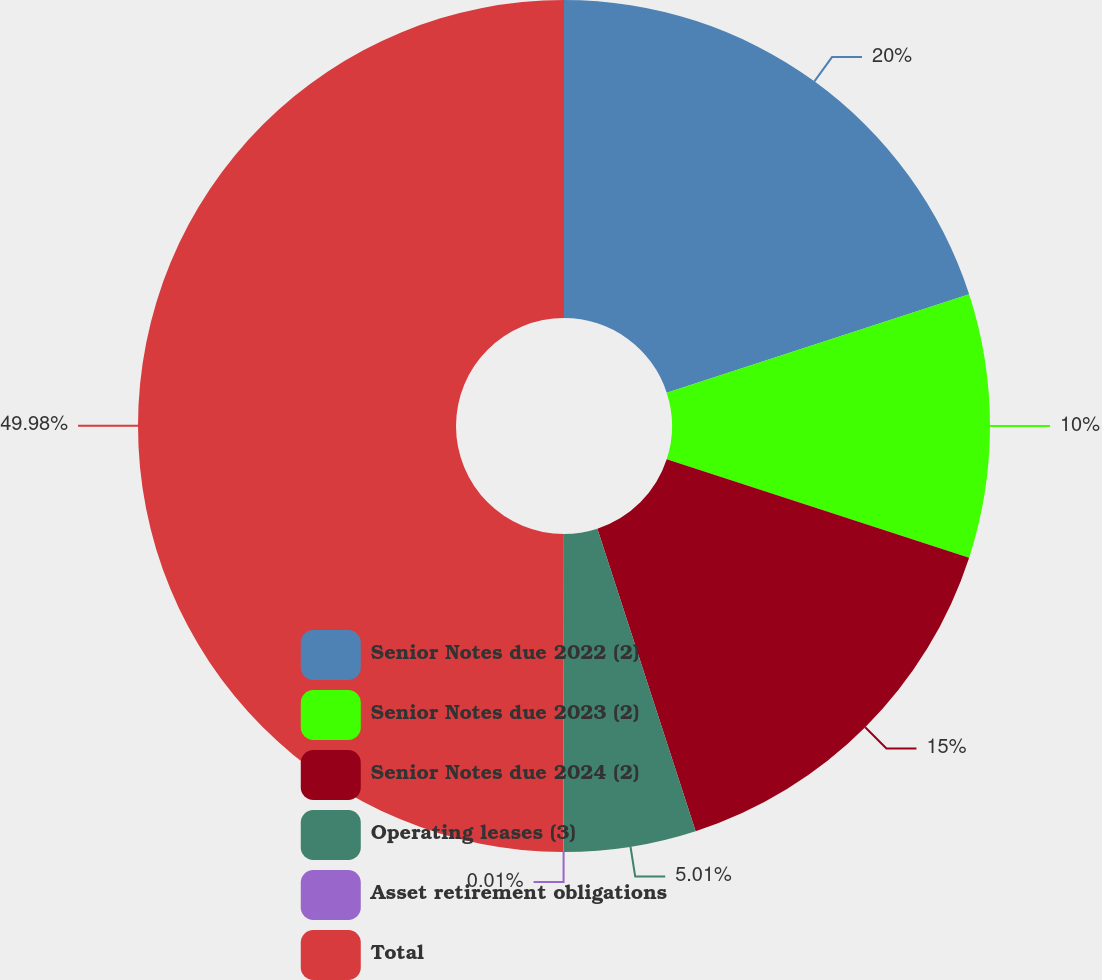<chart> <loc_0><loc_0><loc_500><loc_500><pie_chart><fcel>Senior Notes due 2022 (2)<fcel>Senior Notes due 2023 (2)<fcel>Senior Notes due 2024 (2)<fcel>Operating leases (3)<fcel>Asset retirement obligations<fcel>Total<nl><fcel>20.0%<fcel>10.0%<fcel>15.0%<fcel>5.01%<fcel>0.01%<fcel>49.98%<nl></chart> 